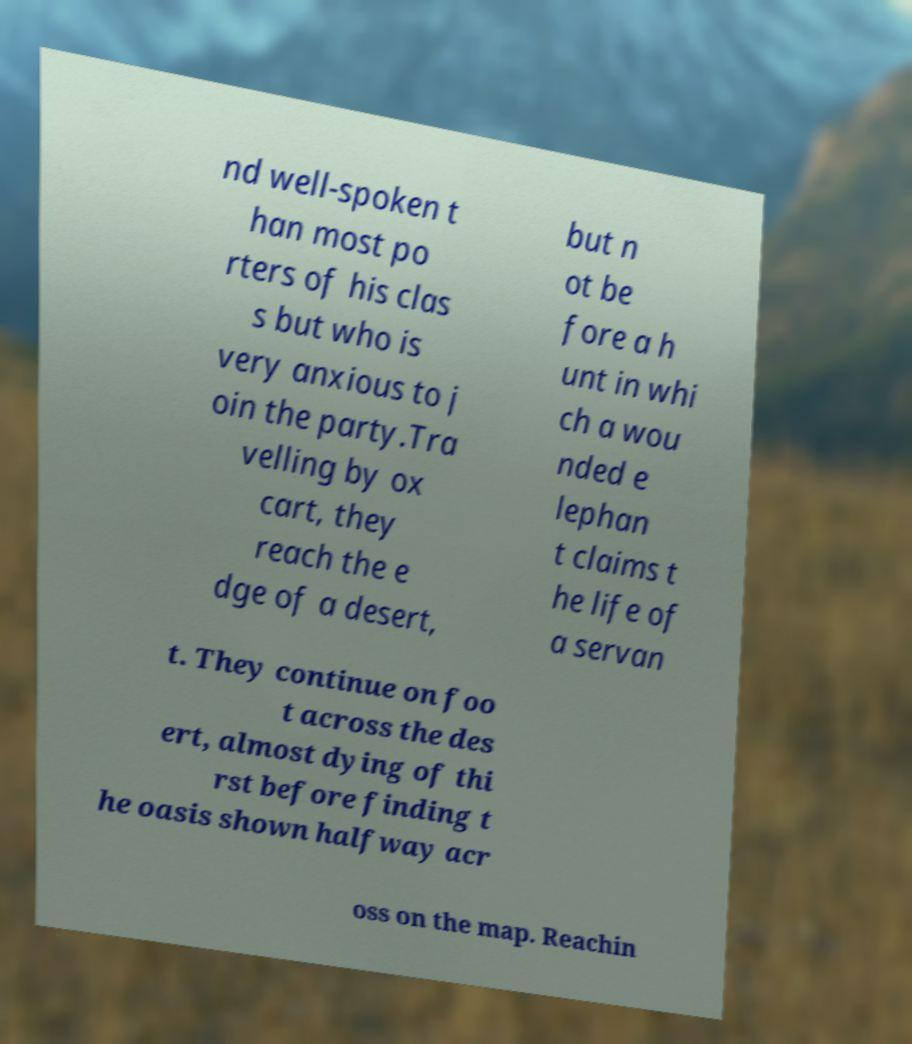Could you assist in decoding the text presented in this image and type it out clearly? nd well-spoken t han most po rters of his clas s but who is very anxious to j oin the party.Tra velling by ox cart, they reach the e dge of a desert, but n ot be fore a h unt in whi ch a wou nded e lephan t claims t he life of a servan t. They continue on foo t across the des ert, almost dying of thi rst before finding t he oasis shown halfway acr oss on the map. Reachin 